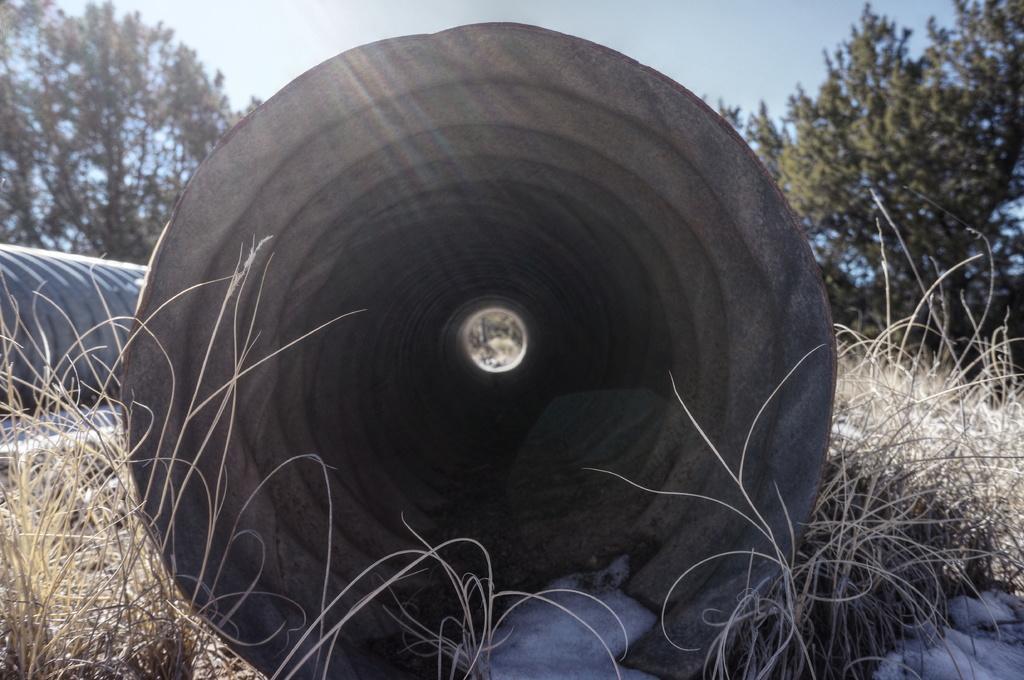Can you describe this image briefly? In this picture I can observe concrete tunnel in the middle of the picture. I can observe some dried grass on the ground. In the background there are trees and sky. 